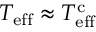<formula> <loc_0><loc_0><loc_500><loc_500>T _ { e f f } \approx T _ { e f f } ^ { c }</formula> 